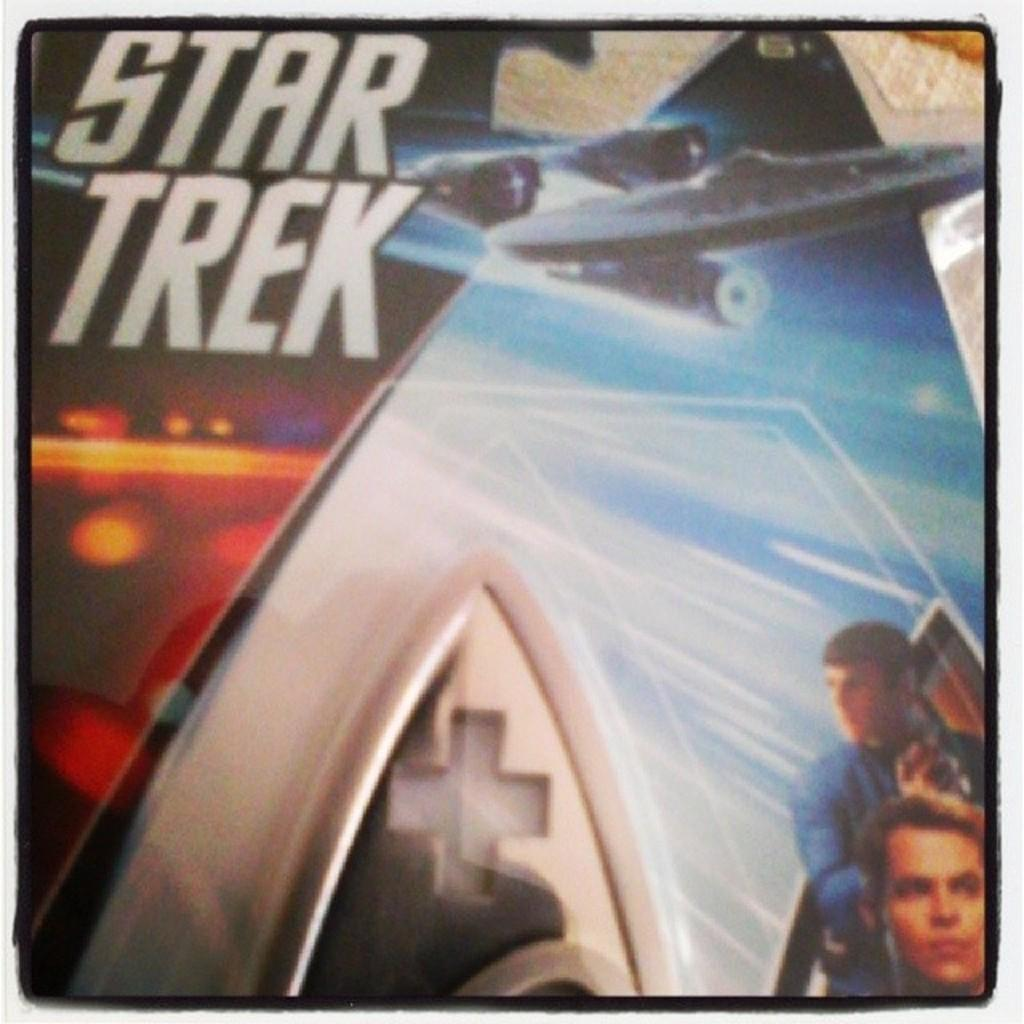What is featured on the poster in the image? The poster in the image has the name "Star Trek" on it. Can you describe the image of the two men under the poster? There is an image of two men under the poster, but their specific appearance or actions cannot be determined from the provided facts. What is the subject matter of the poster? The poster is related to "Star Trek," which is a science fiction franchise. What type of instrument is being played by the man on the left in the image? There is no man playing an instrument in the image; it features a poster with the name "Star Trek" and an image of two men, but their actions or activities are not described in the provided facts. 